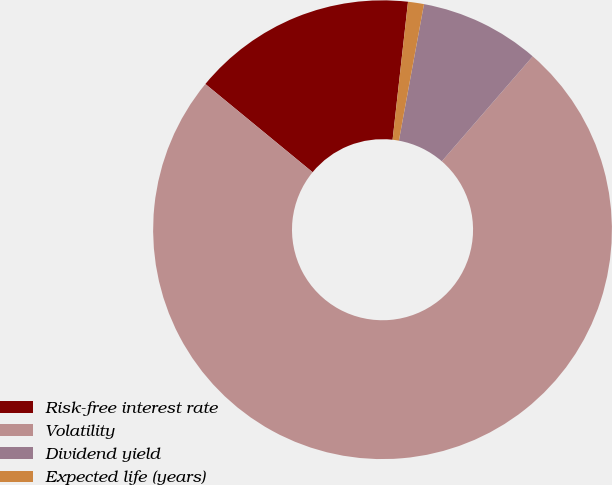Convert chart. <chart><loc_0><loc_0><loc_500><loc_500><pie_chart><fcel>Risk-free interest rate<fcel>Volatility<fcel>Dividend yield<fcel>Expected life (years)<nl><fcel>15.82%<fcel>74.6%<fcel>8.47%<fcel>1.12%<nl></chart> 